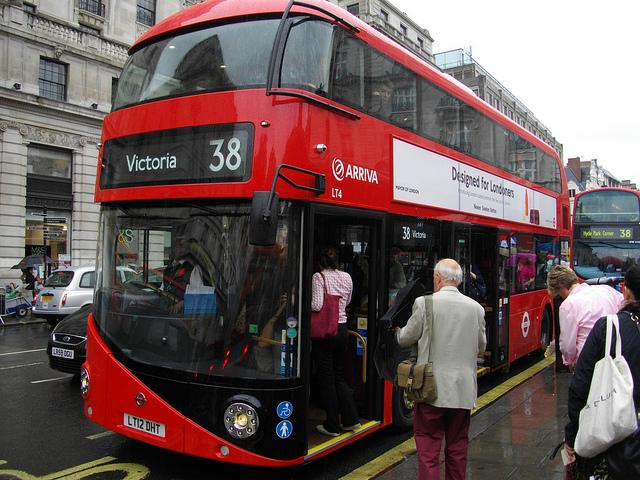What are these people waiting to do? Please explain your reasoning. board bus. They want to get on the bus. 